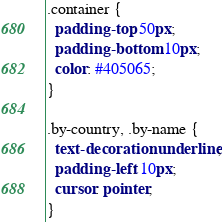<code> <loc_0><loc_0><loc_500><loc_500><_CSS_>
.container {
  padding-top: 50px;
  padding-bottom: 10px;
  color: #405065;
}

.by-country, .by-name {
  text-decoration: underline;
  padding-left: 10px;
  cursor: pointer;
}
</code> 